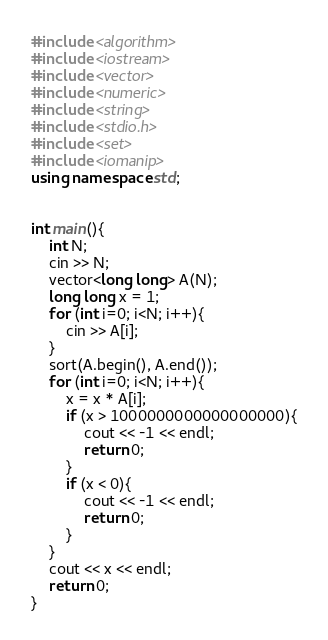<code> <loc_0><loc_0><loc_500><loc_500><_C++_>#include <algorithm>
#include <iostream>
#include <vector>
#include <numeric>
#include <string>
#include <stdio.h>
#include <set>
#include <iomanip>
using namespace std;
 
 
int main(){
    int N;
    cin >> N;
    vector<long long> A(N);
    long long x = 1;
    for (int i=0; i<N; i++){
        cin >> A[i];
    }
    sort(A.begin(), A.end());
    for (int i=0; i<N; i++){
        x = x * A[i];
        if (x > 1000000000000000000){
            cout << -1 << endl;
            return 0;
        }
        if (x < 0){
            cout << -1 << endl;
            return 0;
        }
    }
    cout << x << endl;
    return 0;
}</code> 